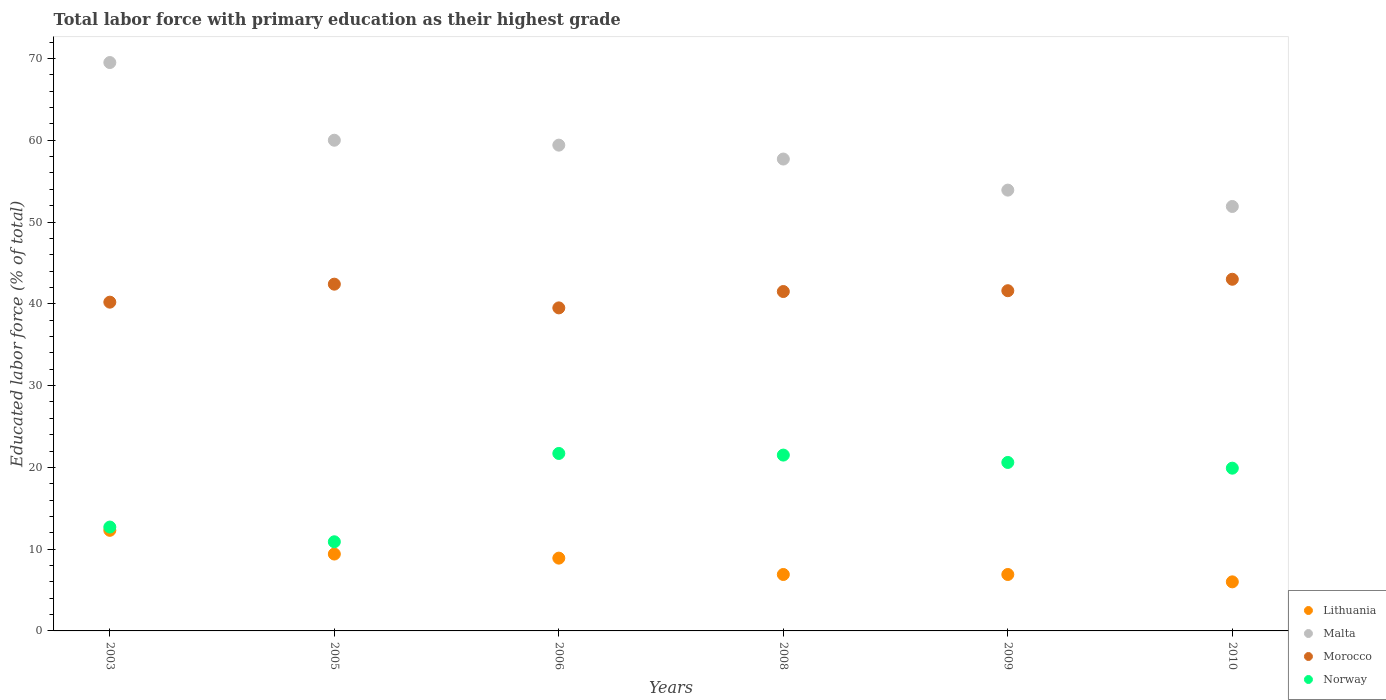What is the percentage of total labor force with primary education in Norway in 2006?
Ensure brevity in your answer.  21.7. Across all years, what is the maximum percentage of total labor force with primary education in Lithuania?
Provide a succinct answer. 12.3. Across all years, what is the minimum percentage of total labor force with primary education in Malta?
Your answer should be compact. 51.9. What is the total percentage of total labor force with primary education in Morocco in the graph?
Offer a very short reply. 248.2. What is the difference between the percentage of total labor force with primary education in Malta in 2008 and that in 2010?
Offer a very short reply. 5.8. What is the average percentage of total labor force with primary education in Morocco per year?
Keep it short and to the point. 41.37. In the year 2009, what is the difference between the percentage of total labor force with primary education in Lithuania and percentage of total labor force with primary education in Morocco?
Your answer should be compact. -34.7. In how many years, is the percentage of total labor force with primary education in Malta greater than 50 %?
Provide a succinct answer. 6. What is the difference between the highest and the second highest percentage of total labor force with primary education in Lithuania?
Provide a short and direct response. 2.9. What is the difference between the highest and the lowest percentage of total labor force with primary education in Norway?
Provide a short and direct response. 10.8. In how many years, is the percentage of total labor force with primary education in Morocco greater than the average percentage of total labor force with primary education in Morocco taken over all years?
Your answer should be very brief. 4. Is the sum of the percentage of total labor force with primary education in Malta in 2003 and 2005 greater than the maximum percentage of total labor force with primary education in Lithuania across all years?
Your answer should be compact. Yes. Does the percentage of total labor force with primary education in Malta monotonically increase over the years?
Provide a short and direct response. No. Is the percentage of total labor force with primary education in Malta strictly less than the percentage of total labor force with primary education in Norway over the years?
Ensure brevity in your answer.  No. Are the values on the major ticks of Y-axis written in scientific E-notation?
Provide a short and direct response. No. Does the graph contain grids?
Your response must be concise. No. What is the title of the graph?
Offer a terse response. Total labor force with primary education as their highest grade. Does "El Salvador" appear as one of the legend labels in the graph?
Give a very brief answer. No. What is the label or title of the X-axis?
Provide a succinct answer. Years. What is the label or title of the Y-axis?
Keep it short and to the point. Educated labor force (% of total). What is the Educated labor force (% of total) of Lithuania in 2003?
Offer a terse response. 12.3. What is the Educated labor force (% of total) in Malta in 2003?
Your response must be concise. 69.5. What is the Educated labor force (% of total) of Morocco in 2003?
Provide a succinct answer. 40.2. What is the Educated labor force (% of total) of Norway in 2003?
Give a very brief answer. 12.7. What is the Educated labor force (% of total) in Lithuania in 2005?
Ensure brevity in your answer.  9.4. What is the Educated labor force (% of total) in Morocco in 2005?
Offer a terse response. 42.4. What is the Educated labor force (% of total) of Norway in 2005?
Provide a succinct answer. 10.9. What is the Educated labor force (% of total) of Lithuania in 2006?
Offer a terse response. 8.9. What is the Educated labor force (% of total) in Malta in 2006?
Give a very brief answer. 59.4. What is the Educated labor force (% of total) in Morocco in 2006?
Your response must be concise. 39.5. What is the Educated labor force (% of total) in Norway in 2006?
Ensure brevity in your answer.  21.7. What is the Educated labor force (% of total) in Lithuania in 2008?
Offer a terse response. 6.9. What is the Educated labor force (% of total) of Malta in 2008?
Your answer should be very brief. 57.7. What is the Educated labor force (% of total) of Morocco in 2008?
Make the answer very short. 41.5. What is the Educated labor force (% of total) of Lithuania in 2009?
Provide a short and direct response. 6.9. What is the Educated labor force (% of total) of Malta in 2009?
Your response must be concise. 53.9. What is the Educated labor force (% of total) of Morocco in 2009?
Ensure brevity in your answer.  41.6. What is the Educated labor force (% of total) in Norway in 2009?
Your answer should be compact. 20.6. What is the Educated labor force (% of total) of Lithuania in 2010?
Keep it short and to the point. 6. What is the Educated labor force (% of total) in Malta in 2010?
Keep it short and to the point. 51.9. What is the Educated labor force (% of total) in Morocco in 2010?
Provide a succinct answer. 43. What is the Educated labor force (% of total) in Norway in 2010?
Ensure brevity in your answer.  19.9. Across all years, what is the maximum Educated labor force (% of total) of Lithuania?
Your answer should be very brief. 12.3. Across all years, what is the maximum Educated labor force (% of total) of Malta?
Ensure brevity in your answer.  69.5. Across all years, what is the maximum Educated labor force (% of total) of Morocco?
Give a very brief answer. 43. Across all years, what is the maximum Educated labor force (% of total) in Norway?
Offer a very short reply. 21.7. Across all years, what is the minimum Educated labor force (% of total) in Malta?
Keep it short and to the point. 51.9. Across all years, what is the minimum Educated labor force (% of total) of Morocco?
Your answer should be very brief. 39.5. Across all years, what is the minimum Educated labor force (% of total) of Norway?
Give a very brief answer. 10.9. What is the total Educated labor force (% of total) in Lithuania in the graph?
Offer a terse response. 50.4. What is the total Educated labor force (% of total) of Malta in the graph?
Provide a short and direct response. 352.4. What is the total Educated labor force (% of total) in Morocco in the graph?
Offer a very short reply. 248.2. What is the total Educated labor force (% of total) in Norway in the graph?
Ensure brevity in your answer.  107.3. What is the difference between the Educated labor force (% of total) in Malta in 2003 and that in 2005?
Offer a terse response. 9.5. What is the difference between the Educated labor force (% of total) of Morocco in 2003 and that in 2005?
Ensure brevity in your answer.  -2.2. What is the difference between the Educated labor force (% of total) of Norway in 2003 and that in 2005?
Your answer should be very brief. 1.8. What is the difference between the Educated labor force (% of total) of Lithuania in 2003 and that in 2006?
Keep it short and to the point. 3.4. What is the difference between the Educated labor force (% of total) of Malta in 2003 and that in 2006?
Keep it short and to the point. 10.1. What is the difference between the Educated labor force (% of total) of Norway in 2003 and that in 2006?
Make the answer very short. -9. What is the difference between the Educated labor force (% of total) in Lithuania in 2003 and that in 2009?
Your response must be concise. 5.4. What is the difference between the Educated labor force (% of total) in Morocco in 2003 and that in 2009?
Keep it short and to the point. -1.4. What is the difference between the Educated labor force (% of total) in Norway in 2003 and that in 2010?
Provide a succinct answer. -7.2. What is the difference between the Educated labor force (% of total) of Morocco in 2005 and that in 2006?
Ensure brevity in your answer.  2.9. What is the difference between the Educated labor force (% of total) in Norway in 2005 and that in 2006?
Your answer should be very brief. -10.8. What is the difference between the Educated labor force (% of total) of Morocco in 2005 and that in 2008?
Provide a succinct answer. 0.9. What is the difference between the Educated labor force (% of total) in Morocco in 2005 and that in 2009?
Make the answer very short. 0.8. What is the difference between the Educated labor force (% of total) of Norway in 2005 and that in 2009?
Provide a succinct answer. -9.7. What is the difference between the Educated labor force (% of total) in Lithuania in 2006 and that in 2008?
Ensure brevity in your answer.  2. What is the difference between the Educated labor force (% of total) of Norway in 2006 and that in 2008?
Your answer should be compact. 0.2. What is the difference between the Educated labor force (% of total) of Malta in 2006 and that in 2009?
Provide a short and direct response. 5.5. What is the difference between the Educated labor force (% of total) in Norway in 2006 and that in 2009?
Your answer should be very brief. 1.1. What is the difference between the Educated labor force (% of total) in Lithuania in 2006 and that in 2010?
Provide a succinct answer. 2.9. What is the difference between the Educated labor force (% of total) of Malta in 2006 and that in 2010?
Give a very brief answer. 7.5. What is the difference between the Educated labor force (% of total) in Morocco in 2006 and that in 2010?
Provide a short and direct response. -3.5. What is the difference between the Educated labor force (% of total) of Norway in 2006 and that in 2010?
Ensure brevity in your answer.  1.8. What is the difference between the Educated labor force (% of total) of Morocco in 2008 and that in 2009?
Provide a succinct answer. -0.1. What is the difference between the Educated labor force (% of total) in Norway in 2008 and that in 2009?
Keep it short and to the point. 0.9. What is the difference between the Educated labor force (% of total) of Malta in 2008 and that in 2010?
Keep it short and to the point. 5.8. What is the difference between the Educated labor force (% of total) of Morocco in 2008 and that in 2010?
Your answer should be very brief. -1.5. What is the difference between the Educated labor force (% of total) in Morocco in 2009 and that in 2010?
Ensure brevity in your answer.  -1.4. What is the difference between the Educated labor force (% of total) of Norway in 2009 and that in 2010?
Your answer should be compact. 0.7. What is the difference between the Educated labor force (% of total) of Lithuania in 2003 and the Educated labor force (% of total) of Malta in 2005?
Your answer should be very brief. -47.7. What is the difference between the Educated labor force (% of total) of Lithuania in 2003 and the Educated labor force (% of total) of Morocco in 2005?
Your answer should be compact. -30.1. What is the difference between the Educated labor force (% of total) in Malta in 2003 and the Educated labor force (% of total) in Morocco in 2005?
Offer a very short reply. 27.1. What is the difference between the Educated labor force (% of total) of Malta in 2003 and the Educated labor force (% of total) of Norway in 2005?
Your response must be concise. 58.6. What is the difference between the Educated labor force (% of total) in Morocco in 2003 and the Educated labor force (% of total) in Norway in 2005?
Your response must be concise. 29.3. What is the difference between the Educated labor force (% of total) of Lithuania in 2003 and the Educated labor force (% of total) of Malta in 2006?
Your answer should be compact. -47.1. What is the difference between the Educated labor force (% of total) of Lithuania in 2003 and the Educated labor force (% of total) of Morocco in 2006?
Provide a short and direct response. -27.2. What is the difference between the Educated labor force (% of total) of Malta in 2003 and the Educated labor force (% of total) of Morocco in 2006?
Provide a short and direct response. 30. What is the difference between the Educated labor force (% of total) in Malta in 2003 and the Educated labor force (% of total) in Norway in 2006?
Your answer should be very brief. 47.8. What is the difference between the Educated labor force (% of total) in Morocco in 2003 and the Educated labor force (% of total) in Norway in 2006?
Your answer should be compact. 18.5. What is the difference between the Educated labor force (% of total) in Lithuania in 2003 and the Educated labor force (% of total) in Malta in 2008?
Give a very brief answer. -45.4. What is the difference between the Educated labor force (% of total) of Lithuania in 2003 and the Educated labor force (% of total) of Morocco in 2008?
Your response must be concise. -29.2. What is the difference between the Educated labor force (% of total) in Lithuania in 2003 and the Educated labor force (% of total) in Norway in 2008?
Your response must be concise. -9.2. What is the difference between the Educated labor force (% of total) in Morocco in 2003 and the Educated labor force (% of total) in Norway in 2008?
Your response must be concise. 18.7. What is the difference between the Educated labor force (% of total) in Lithuania in 2003 and the Educated labor force (% of total) in Malta in 2009?
Ensure brevity in your answer.  -41.6. What is the difference between the Educated labor force (% of total) in Lithuania in 2003 and the Educated labor force (% of total) in Morocco in 2009?
Your answer should be very brief. -29.3. What is the difference between the Educated labor force (% of total) of Malta in 2003 and the Educated labor force (% of total) of Morocco in 2009?
Make the answer very short. 27.9. What is the difference between the Educated labor force (% of total) of Malta in 2003 and the Educated labor force (% of total) of Norway in 2009?
Keep it short and to the point. 48.9. What is the difference between the Educated labor force (% of total) of Morocco in 2003 and the Educated labor force (% of total) of Norway in 2009?
Provide a succinct answer. 19.6. What is the difference between the Educated labor force (% of total) of Lithuania in 2003 and the Educated labor force (% of total) of Malta in 2010?
Provide a short and direct response. -39.6. What is the difference between the Educated labor force (% of total) in Lithuania in 2003 and the Educated labor force (% of total) in Morocco in 2010?
Offer a very short reply. -30.7. What is the difference between the Educated labor force (% of total) of Malta in 2003 and the Educated labor force (% of total) of Morocco in 2010?
Provide a short and direct response. 26.5. What is the difference between the Educated labor force (% of total) of Malta in 2003 and the Educated labor force (% of total) of Norway in 2010?
Give a very brief answer. 49.6. What is the difference between the Educated labor force (% of total) in Morocco in 2003 and the Educated labor force (% of total) in Norway in 2010?
Make the answer very short. 20.3. What is the difference between the Educated labor force (% of total) of Lithuania in 2005 and the Educated labor force (% of total) of Morocco in 2006?
Make the answer very short. -30.1. What is the difference between the Educated labor force (% of total) of Lithuania in 2005 and the Educated labor force (% of total) of Norway in 2006?
Keep it short and to the point. -12.3. What is the difference between the Educated labor force (% of total) of Malta in 2005 and the Educated labor force (% of total) of Morocco in 2006?
Your answer should be compact. 20.5. What is the difference between the Educated labor force (% of total) of Malta in 2005 and the Educated labor force (% of total) of Norway in 2006?
Ensure brevity in your answer.  38.3. What is the difference between the Educated labor force (% of total) in Morocco in 2005 and the Educated labor force (% of total) in Norway in 2006?
Your answer should be very brief. 20.7. What is the difference between the Educated labor force (% of total) in Lithuania in 2005 and the Educated labor force (% of total) in Malta in 2008?
Your answer should be very brief. -48.3. What is the difference between the Educated labor force (% of total) of Lithuania in 2005 and the Educated labor force (% of total) of Morocco in 2008?
Your answer should be compact. -32.1. What is the difference between the Educated labor force (% of total) of Malta in 2005 and the Educated labor force (% of total) of Norway in 2008?
Make the answer very short. 38.5. What is the difference between the Educated labor force (% of total) of Morocco in 2005 and the Educated labor force (% of total) of Norway in 2008?
Provide a short and direct response. 20.9. What is the difference between the Educated labor force (% of total) of Lithuania in 2005 and the Educated labor force (% of total) of Malta in 2009?
Offer a very short reply. -44.5. What is the difference between the Educated labor force (% of total) in Lithuania in 2005 and the Educated labor force (% of total) in Morocco in 2009?
Give a very brief answer. -32.2. What is the difference between the Educated labor force (% of total) of Malta in 2005 and the Educated labor force (% of total) of Norway in 2009?
Offer a very short reply. 39.4. What is the difference between the Educated labor force (% of total) of Morocco in 2005 and the Educated labor force (% of total) of Norway in 2009?
Make the answer very short. 21.8. What is the difference between the Educated labor force (% of total) of Lithuania in 2005 and the Educated labor force (% of total) of Malta in 2010?
Provide a short and direct response. -42.5. What is the difference between the Educated labor force (% of total) of Lithuania in 2005 and the Educated labor force (% of total) of Morocco in 2010?
Your answer should be compact. -33.6. What is the difference between the Educated labor force (% of total) in Lithuania in 2005 and the Educated labor force (% of total) in Norway in 2010?
Give a very brief answer. -10.5. What is the difference between the Educated labor force (% of total) in Malta in 2005 and the Educated labor force (% of total) in Norway in 2010?
Give a very brief answer. 40.1. What is the difference between the Educated labor force (% of total) in Morocco in 2005 and the Educated labor force (% of total) in Norway in 2010?
Provide a succinct answer. 22.5. What is the difference between the Educated labor force (% of total) in Lithuania in 2006 and the Educated labor force (% of total) in Malta in 2008?
Ensure brevity in your answer.  -48.8. What is the difference between the Educated labor force (% of total) of Lithuania in 2006 and the Educated labor force (% of total) of Morocco in 2008?
Offer a very short reply. -32.6. What is the difference between the Educated labor force (% of total) in Malta in 2006 and the Educated labor force (% of total) in Morocco in 2008?
Provide a succinct answer. 17.9. What is the difference between the Educated labor force (% of total) of Malta in 2006 and the Educated labor force (% of total) of Norway in 2008?
Give a very brief answer. 37.9. What is the difference between the Educated labor force (% of total) in Morocco in 2006 and the Educated labor force (% of total) in Norway in 2008?
Offer a terse response. 18. What is the difference between the Educated labor force (% of total) of Lithuania in 2006 and the Educated labor force (% of total) of Malta in 2009?
Offer a terse response. -45. What is the difference between the Educated labor force (% of total) of Lithuania in 2006 and the Educated labor force (% of total) of Morocco in 2009?
Offer a very short reply. -32.7. What is the difference between the Educated labor force (% of total) of Lithuania in 2006 and the Educated labor force (% of total) of Norway in 2009?
Provide a short and direct response. -11.7. What is the difference between the Educated labor force (% of total) of Malta in 2006 and the Educated labor force (% of total) of Norway in 2009?
Give a very brief answer. 38.8. What is the difference between the Educated labor force (% of total) in Lithuania in 2006 and the Educated labor force (% of total) in Malta in 2010?
Your response must be concise. -43. What is the difference between the Educated labor force (% of total) of Lithuania in 2006 and the Educated labor force (% of total) of Morocco in 2010?
Keep it short and to the point. -34.1. What is the difference between the Educated labor force (% of total) of Lithuania in 2006 and the Educated labor force (% of total) of Norway in 2010?
Your answer should be compact. -11. What is the difference between the Educated labor force (% of total) in Malta in 2006 and the Educated labor force (% of total) in Morocco in 2010?
Make the answer very short. 16.4. What is the difference between the Educated labor force (% of total) in Malta in 2006 and the Educated labor force (% of total) in Norway in 2010?
Your answer should be very brief. 39.5. What is the difference between the Educated labor force (% of total) in Morocco in 2006 and the Educated labor force (% of total) in Norway in 2010?
Your answer should be compact. 19.6. What is the difference between the Educated labor force (% of total) of Lithuania in 2008 and the Educated labor force (% of total) of Malta in 2009?
Give a very brief answer. -47. What is the difference between the Educated labor force (% of total) in Lithuania in 2008 and the Educated labor force (% of total) in Morocco in 2009?
Your response must be concise. -34.7. What is the difference between the Educated labor force (% of total) in Lithuania in 2008 and the Educated labor force (% of total) in Norway in 2009?
Your answer should be very brief. -13.7. What is the difference between the Educated labor force (% of total) of Malta in 2008 and the Educated labor force (% of total) of Morocco in 2009?
Your answer should be very brief. 16.1. What is the difference between the Educated labor force (% of total) in Malta in 2008 and the Educated labor force (% of total) in Norway in 2009?
Keep it short and to the point. 37.1. What is the difference between the Educated labor force (% of total) of Morocco in 2008 and the Educated labor force (% of total) of Norway in 2009?
Make the answer very short. 20.9. What is the difference between the Educated labor force (% of total) of Lithuania in 2008 and the Educated labor force (% of total) of Malta in 2010?
Your response must be concise. -45. What is the difference between the Educated labor force (% of total) in Lithuania in 2008 and the Educated labor force (% of total) in Morocco in 2010?
Provide a short and direct response. -36.1. What is the difference between the Educated labor force (% of total) in Lithuania in 2008 and the Educated labor force (% of total) in Norway in 2010?
Provide a short and direct response. -13. What is the difference between the Educated labor force (% of total) in Malta in 2008 and the Educated labor force (% of total) in Norway in 2010?
Ensure brevity in your answer.  37.8. What is the difference between the Educated labor force (% of total) in Morocco in 2008 and the Educated labor force (% of total) in Norway in 2010?
Your answer should be compact. 21.6. What is the difference between the Educated labor force (% of total) in Lithuania in 2009 and the Educated labor force (% of total) in Malta in 2010?
Provide a short and direct response. -45. What is the difference between the Educated labor force (% of total) of Lithuania in 2009 and the Educated labor force (% of total) of Morocco in 2010?
Give a very brief answer. -36.1. What is the difference between the Educated labor force (% of total) in Lithuania in 2009 and the Educated labor force (% of total) in Norway in 2010?
Offer a terse response. -13. What is the difference between the Educated labor force (% of total) of Malta in 2009 and the Educated labor force (% of total) of Morocco in 2010?
Your answer should be very brief. 10.9. What is the difference between the Educated labor force (% of total) of Malta in 2009 and the Educated labor force (% of total) of Norway in 2010?
Offer a terse response. 34. What is the difference between the Educated labor force (% of total) of Morocco in 2009 and the Educated labor force (% of total) of Norway in 2010?
Offer a terse response. 21.7. What is the average Educated labor force (% of total) of Lithuania per year?
Give a very brief answer. 8.4. What is the average Educated labor force (% of total) in Malta per year?
Provide a short and direct response. 58.73. What is the average Educated labor force (% of total) in Morocco per year?
Your answer should be compact. 41.37. What is the average Educated labor force (% of total) of Norway per year?
Offer a very short reply. 17.88. In the year 2003, what is the difference between the Educated labor force (% of total) in Lithuania and Educated labor force (% of total) in Malta?
Offer a very short reply. -57.2. In the year 2003, what is the difference between the Educated labor force (% of total) in Lithuania and Educated labor force (% of total) in Morocco?
Your answer should be compact. -27.9. In the year 2003, what is the difference between the Educated labor force (% of total) of Malta and Educated labor force (% of total) of Morocco?
Give a very brief answer. 29.3. In the year 2003, what is the difference between the Educated labor force (% of total) of Malta and Educated labor force (% of total) of Norway?
Provide a succinct answer. 56.8. In the year 2003, what is the difference between the Educated labor force (% of total) of Morocco and Educated labor force (% of total) of Norway?
Your response must be concise. 27.5. In the year 2005, what is the difference between the Educated labor force (% of total) in Lithuania and Educated labor force (% of total) in Malta?
Provide a succinct answer. -50.6. In the year 2005, what is the difference between the Educated labor force (% of total) of Lithuania and Educated labor force (% of total) of Morocco?
Provide a short and direct response. -33. In the year 2005, what is the difference between the Educated labor force (% of total) in Malta and Educated labor force (% of total) in Norway?
Offer a very short reply. 49.1. In the year 2005, what is the difference between the Educated labor force (% of total) of Morocco and Educated labor force (% of total) of Norway?
Offer a terse response. 31.5. In the year 2006, what is the difference between the Educated labor force (% of total) in Lithuania and Educated labor force (% of total) in Malta?
Offer a terse response. -50.5. In the year 2006, what is the difference between the Educated labor force (% of total) in Lithuania and Educated labor force (% of total) in Morocco?
Your answer should be compact. -30.6. In the year 2006, what is the difference between the Educated labor force (% of total) of Lithuania and Educated labor force (% of total) of Norway?
Offer a very short reply. -12.8. In the year 2006, what is the difference between the Educated labor force (% of total) in Malta and Educated labor force (% of total) in Morocco?
Your response must be concise. 19.9. In the year 2006, what is the difference between the Educated labor force (% of total) of Malta and Educated labor force (% of total) of Norway?
Provide a short and direct response. 37.7. In the year 2008, what is the difference between the Educated labor force (% of total) in Lithuania and Educated labor force (% of total) in Malta?
Your answer should be very brief. -50.8. In the year 2008, what is the difference between the Educated labor force (% of total) in Lithuania and Educated labor force (% of total) in Morocco?
Give a very brief answer. -34.6. In the year 2008, what is the difference between the Educated labor force (% of total) in Lithuania and Educated labor force (% of total) in Norway?
Your response must be concise. -14.6. In the year 2008, what is the difference between the Educated labor force (% of total) in Malta and Educated labor force (% of total) in Morocco?
Your response must be concise. 16.2. In the year 2008, what is the difference between the Educated labor force (% of total) in Malta and Educated labor force (% of total) in Norway?
Keep it short and to the point. 36.2. In the year 2008, what is the difference between the Educated labor force (% of total) in Morocco and Educated labor force (% of total) in Norway?
Provide a succinct answer. 20. In the year 2009, what is the difference between the Educated labor force (% of total) of Lithuania and Educated labor force (% of total) of Malta?
Give a very brief answer. -47. In the year 2009, what is the difference between the Educated labor force (% of total) of Lithuania and Educated labor force (% of total) of Morocco?
Make the answer very short. -34.7. In the year 2009, what is the difference between the Educated labor force (% of total) of Lithuania and Educated labor force (% of total) of Norway?
Your answer should be very brief. -13.7. In the year 2009, what is the difference between the Educated labor force (% of total) of Malta and Educated labor force (% of total) of Norway?
Offer a terse response. 33.3. In the year 2010, what is the difference between the Educated labor force (% of total) in Lithuania and Educated labor force (% of total) in Malta?
Make the answer very short. -45.9. In the year 2010, what is the difference between the Educated labor force (% of total) in Lithuania and Educated labor force (% of total) in Morocco?
Your response must be concise. -37. In the year 2010, what is the difference between the Educated labor force (% of total) of Malta and Educated labor force (% of total) of Morocco?
Provide a succinct answer. 8.9. In the year 2010, what is the difference between the Educated labor force (% of total) in Malta and Educated labor force (% of total) in Norway?
Give a very brief answer. 32. In the year 2010, what is the difference between the Educated labor force (% of total) in Morocco and Educated labor force (% of total) in Norway?
Your answer should be compact. 23.1. What is the ratio of the Educated labor force (% of total) of Lithuania in 2003 to that in 2005?
Give a very brief answer. 1.31. What is the ratio of the Educated labor force (% of total) in Malta in 2003 to that in 2005?
Ensure brevity in your answer.  1.16. What is the ratio of the Educated labor force (% of total) in Morocco in 2003 to that in 2005?
Offer a very short reply. 0.95. What is the ratio of the Educated labor force (% of total) in Norway in 2003 to that in 2005?
Keep it short and to the point. 1.17. What is the ratio of the Educated labor force (% of total) of Lithuania in 2003 to that in 2006?
Ensure brevity in your answer.  1.38. What is the ratio of the Educated labor force (% of total) of Malta in 2003 to that in 2006?
Provide a succinct answer. 1.17. What is the ratio of the Educated labor force (% of total) of Morocco in 2003 to that in 2006?
Provide a short and direct response. 1.02. What is the ratio of the Educated labor force (% of total) of Norway in 2003 to that in 2006?
Ensure brevity in your answer.  0.59. What is the ratio of the Educated labor force (% of total) in Lithuania in 2003 to that in 2008?
Ensure brevity in your answer.  1.78. What is the ratio of the Educated labor force (% of total) of Malta in 2003 to that in 2008?
Your answer should be very brief. 1.2. What is the ratio of the Educated labor force (% of total) in Morocco in 2003 to that in 2008?
Make the answer very short. 0.97. What is the ratio of the Educated labor force (% of total) of Norway in 2003 to that in 2008?
Offer a very short reply. 0.59. What is the ratio of the Educated labor force (% of total) of Lithuania in 2003 to that in 2009?
Provide a succinct answer. 1.78. What is the ratio of the Educated labor force (% of total) of Malta in 2003 to that in 2009?
Make the answer very short. 1.29. What is the ratio of the Educated labor force (% of total) of Morocco in 2003 to that in 2009?
Ensure brevity in your answer.  0.97. What is the ratio of the Educated labor force (% of total) in Norway in 2003 to that in 2009?
Your answer should be compact. 0.62. What is the ratio of the Educated labor force (% of total) in Lithuania in 2003 to that in 2010?
Your answer should be compact. 2.05. What is the ratio of the Educated labor force (% of total) in Malta in 2003 to that in 2010?
Provide a short and direct response. 1.34. What is the ratio of the Educated labor force (% of total) of Morocco in 2003 to that in 2010?
Offer a very short reply. 0.93. What is the ratio of the Educated labor force (% of total) of Norway in 2003 to that in 2010?
Provide a succinct answer. 0.64. What is the ratio of the Educated labor force (% of total) of Lithuania in 2005 to that in 2006?
Offer a very short reply. 1.06. What is the ratio of the Educated labor force (% of total) of Malta in 2005 to that in 2006?
Give a very brief answer. 1.01. What is the ratio of the Educated labor force (% of total) in Morocco in 2005 to that in 2006?
Your answer should be compact. 1.07. What is the ratio of the Educated labor force (% of total) in Norway in 2005 to that in 2006?
Your answer should be very brief. 0.5. What is the ratio of the Educated labor force (% of total) in Lithuania in 2005 to that in 2008?
Your answer should be compact. 1.36. What is the ratio of the Educated labor force (% of total) in Malta in 2005 to that in 2008?
Your response must be concise. 1.04. What is the ratio of the Educated labor force (% of total) in Morocco in 2005 to that in 2008?
Give a very brief answer. 1.02. What is the ratio of the Educated labor force (% of total) of Norway in 2005 to that in 2008?
Offer a very short reply. 0.51. What is the ratio of the Educated labor force (% of total) in Lithuania in 2005 to that in 2009?
Your answer should be very brief. 1.36. What is the ratio of the Educated labor force (% of total) of Malta in 2005 to that in 2009?
Ensure brevity in your answer.  1.11. What is the ratio of the Educated labor force (% of total) of Morocco in 2005 to that in 2009?
Offer a very short reply. 1.02. What is the ratio of the Educated labor force (% of total) of Norway in 2005 to that in 2009?
Offer a very short reply. 0.53. What is the ratio of the Educated labor force (% of total) of Lithuania in 2005 to that in 2010?
Offer a terse response. 1.57. What is the ratio of the Educated labor force (% of total) in Malta in 2005 to that in 2010?
Make the answer very short. 1.16. What is the ratio of the Educated labor force (% of total) in Norway in 2005 to that in 2010?
Keep it short and to the point. 0.55. What is the ratio of the Educated labor force (% of total) of Lithuania in 2006 to that in 2008?
Your response must be concise. 1.29. What is the ratio of the Educated labor force (% of total) of Malta in 2006 to that in 2008?
Make the answer very short. 1.03. What is the ratio of the Educated labor force (% of total) of Morocco in 2006 to that in 2008?
Ensure brevity in your answer.  0.95. What is the ratio of the Educated labor force (% of total) of Norway in 2006 to that in 2008?
Offer a terse response. 1.01. What is the ratio of the Educated labor force (% of total) in Lithuania in 2006 to that in 2009?
Offer a terse response. 1.29. What is the ratio of the Educated labor force (% of total) of Malta in 2006 to that in 2009?
Give a very brief answer. 1.1. What is the ratio of the Educated labor force (% of total) of Morocco in 2006 to that in 2009?
Your response must be concise. 0.95. What is the ratio of the Educated labor force (% of total) of Norway in 2006 to that in 2009?
Your answer should be very brief. 1.05. What is the ratio of the Educated labor force (% of total) of Lithuania in 2006 to that in 2010?
Offer a terse response. 1.48. What is the ratio of the Educated labor force (% of total) of Malta in 2006 to that in 2010?
Your answer should be compact. 1.14. What is the ratio of the Educated labor force (% of total) in Morocco in 2006 to that in 2010?
Your response must be concise. 0.92. What is the ratio of the Educated labor force (% of total) in Norway in 2006 to that in 2010?
Give a very brief answer. 1.09. What is the ratio of the Educated labor force (% of total) of Malta in 2008 to that in 2009?
Your response must be concise. 1.07. What is the ratio of the Educated labor force (% of total) in Norway in 2008 to that in 2009?
Give a very brief answer. 1.04. What is the ratio of the Educated labor force (% of total) in Lithuania in 2008 to that in 2010?
Ensure brevity in your answer.  1.15. What is the ratio of the Educated labor force (% of total) in Malta in 2008 to that in 2010?
Ensure brevity in your answer.  1.11. What is the ratio of the Educated labor force (% of total) of Morocco in 2008 to that in 2010?
Your answer should be compact. 0.97. What is the ratio of the Educated labor force (% of total) of Norway in 2008 to that in 2010?
Your answer should be very brief. 1.08. What is the ratio of the Educated labor force (% of total) in Lithuania in 2009 to that in 2010?
Ensure brevity in your answer.  1.15. What is the ratio of the Educated labor force (% of total) of Morocco in 2009 to that in 2010?
Offer a very short reply. 0.97. What is the ratio of the Educated labor force (% of total) of Norway in 2009 to that in 2010?
Make the answer very short. 1.04. What is the difference between the highest and the second highest Educated labor force (% of total) of Lithuania?
Your response must be concise. 2.9. What is the difference between the highest and the lowest Educated labor force (% of total) in Malta?
Make the answer very short. 17.6. What is the difference between the highest and the lowest Educated labor force (% of total) in Morocco?
Keep it short and to the point. 3.5. 